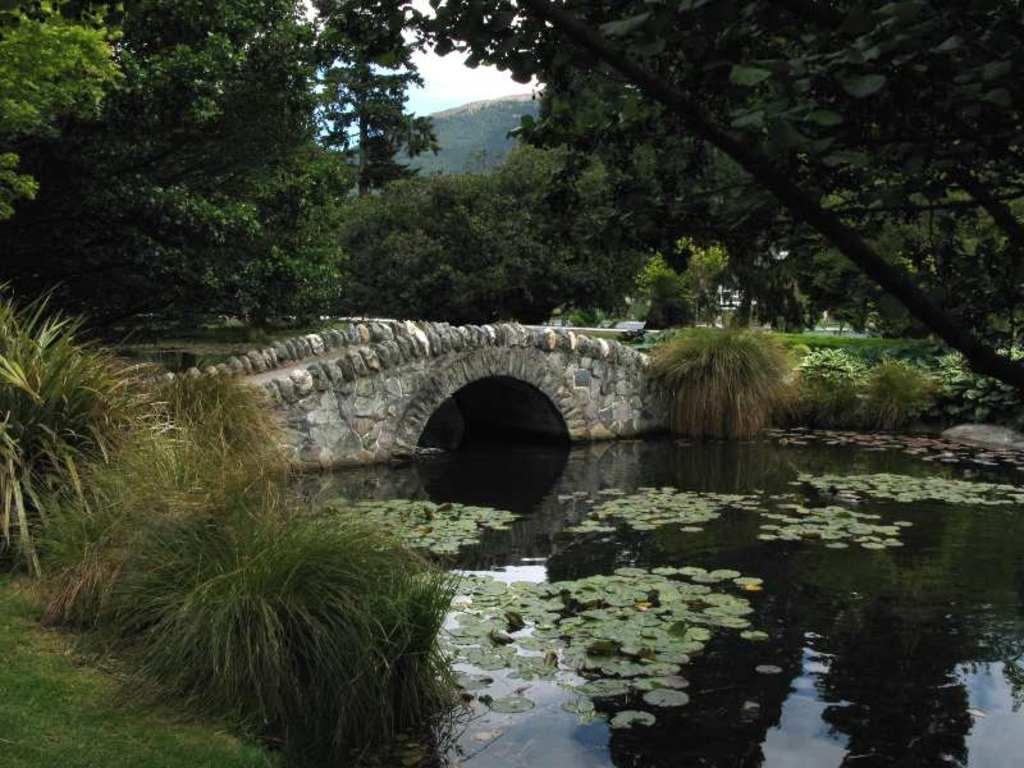What type of vegetation can be seen in the image? There are trees in the image. What type of structure is present in the image? There is a foot over bridge in the image. What natural element is visible in the image? There is water visible in the image. What is the condition of the sky in the image? The sky is cloudy in the image. Can you tell me how many drums are being played by the maid in the image? There is no maid or drum present in the image. What idea does the image represent? The image does not represent a specific idea; it is a visual representation of trees, a foot over bridge, water, and a cloudy sky. 